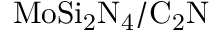<formula> <loc_0><loc_0><loc_500><loc_500>M o S i _ { 2 } N _ { 4 } / C _ { 2 } N</formula> 